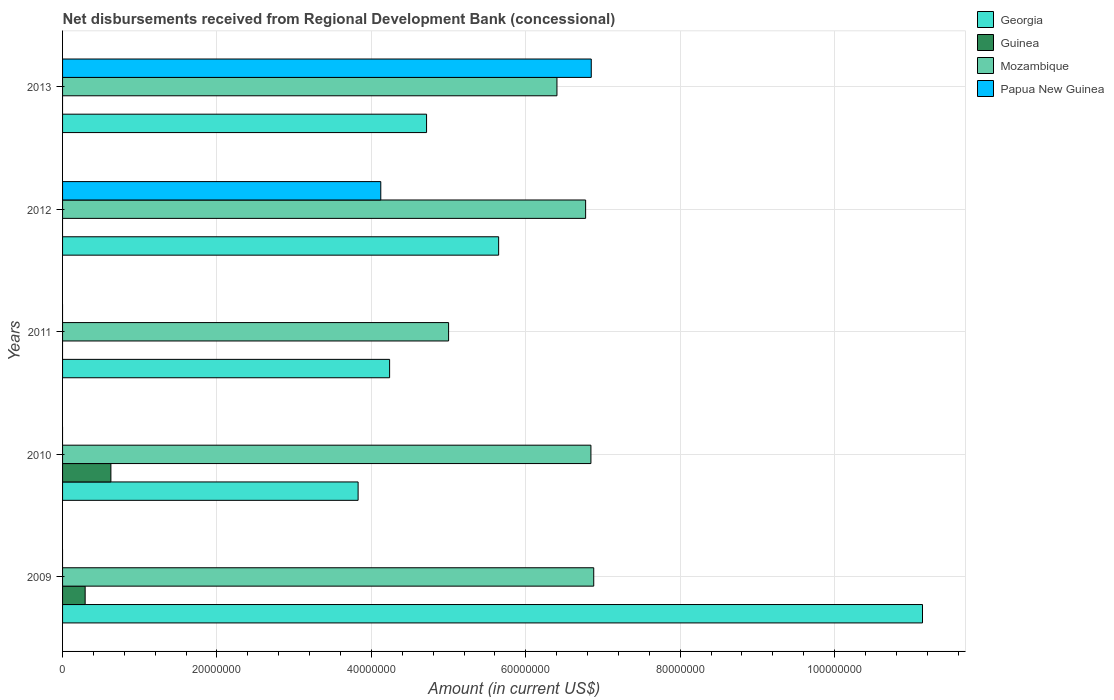How many different coloured bars are there?
Ensure brevity in your answer.  4. In how many cases, is the number of bars for a given year not equal to the number of legend labels?
Your answer should be compact. 5. What is the amount of disbursements received from Regional Development Bank in Guinea in 2009?
Your answer should be very brief. 2.93e+06. Across all years, what is the maximum amount of disbursements received from Regional Development Bank in Mozambique?
Give a very brief answer. 6.88e+07. Across all years, what is the minimum amount of disbursements received from Regional Development Bank in Mozambique?
Provide a short and direct response. 5.00e+07. In which year was the amount of disbursements received from Regional Development Bank in Georgia maximum?
Make the answer very short. 2009. What is the total amount of disbursements received from Regional Development Bank in Mozambique in the graph?
Keep it short and to the point. 3.19e+08. What is the difference between the amount of disbursements received from Regional Development Bank in Georgia in 2012 and that in 2013?
Provide a succinct answer. 9.34e+06. What is the difference between the amount of disbursements received from Regional Development Bank in Georgia in 2011 and the amount of disbursements received from Regional Development Bank in Guinea in 2012?
Your answer should be very brief. 4.24e+07. What is the average amount of disbursements received from Regional Development Bank in Mozambique per year?
Make the answer very short. 6.38e+07. In the year 2011, what is the difference between the amount of disbursements received from Regional Development Bank in Mozambique and amount of disbursements received from Regional Development Bank in Georgia?
Offer a very short reply. 7.64e+06. What is the ratio of the amount of disbursements received from Regional Development Bank in Papua New Guinea in 2012 to that in 2013?
Provide a succinct answer. 0.6. Is the amount of disbursements received from Regional Development Bank in Georgia in 2010 less than that in 2013?
Make the answer very short. Yes. Is the difference between the amount of disbursements received from Regional Development Bank in Mozambique in 2010 and 2011 greater than the difference between the amount of disbursements received from Regional Development Bank in Georgia in 2010 and 2011?
Ensure brevity in your answer.  Yes. What is the difference between the highest and the second highest amount of disbursements received from Regional Development Bank in Georgia?
Offer a very short reply. 5.49e+07. What is the difference between the highest and the lowest amount of disbursements received from Regional Development Bank in Papua New Guinea?
Your answer should be very brief. 6.85e+07. In how many years, is the amount of disbursements received from Regional Development Bank in Papua New Guinea greater than the average amount of disbursements received from Regional Development Bank in Papua New Guinea taken over all years?
Provide a short and direct response. 2. Is the sum of the amount of disbursements received from Regional Development Bank in Georgia in 2009 and 2013 greater than the maximum amount of disbursements received from Regional Development Bank in Mozambique across all years?
Your answer should be very brief. Yes. Does the graph contain grids?
Provide a short and direct response. Yes. How are the legend labels stacked?
Give a very brief answer. Vertical. What is the title of the graph?
Keep it short and to the point. Net disbursements received from Regional Development Bank (concessional). Does "Nepal" appear as one of the legend labels in the graph?
Offer a terse response. No. What is the label or title of the Y-axis?
Provide a succinct answer. Years. What is the Amount (in current US$) in Georgia in 2009?
Give a very brief answer. 1.11e+08. What is the Amount (in current US$) in Guinea in 2009?
Provide a succinct answer. 2.93e+06. What is the Amount (in current US$) of Mozambique in 2009?
Offer a terse response. 6.88e+07. What is the Amount (in current US$) of Georgia in 2010?
Your answer should be compact. 3.83e+07. What is the Amount (in current US$) of Guinea in 2010?
Keep it short and to the point. 6.26e+06. What is the Amount (in current US$) of Mozambique in 2010?
Your response must be concise. 6.84e+07. What is the Amount (in current US$) in Georgia in 2011?
Offer a very short reply. 4.24e+07. What is the Amount (in current US$) of Guinea in 2011?
Keep it short and to the point. 0. What is the Amount (in current US$) of Mozambique in 2011?
Your response must be concise. 5.00e+07. What is the Amount (in current US$) in Georgia in 2012?
Ensure brevity in your answer.  5.65e+07. What is the Amount (in current US$) in Guinea in 2012?
Give a very brief answer. 0. What is the Amount (in current US$) in Mozambique in 2012?
Offer a very short reply. 6.78e+07. What is the Amount (in current US$) in Papua New Guinea in 2012?
Offer a very short reply. 4.12e+07. What is the Amount (in current US$) of Georgia in 2013?
Your answer should be compact. 4.72e+07. What is the Amount (in current US$) in Mozambique in 2013?
Your answer should be compact. 6.40e+07. What is the Amount (in current US$) of Papua New Guinea in 2013?
Offer a terse response. 6.85e+07. Across all years, what is the maximum Amount (in current US$) in Georgia?
Keep it short and to the point. 1.11e+08. Across all years, what is the maximum Amount (in current US$) of Guinea?
Offer a very short reply. 6.26e+06. Across all years, what is the maximum Amount (in current US$) in Mozambique?
Offer a very short reply. 6.88e+07. Across all years, what is the maximum Amount (in current US$) of Papua New Guinea?
Offer a terse response. 6.85e+07. Across all years, what is the minimum Amount (in current US$) in Georgia?
Offer a terse response. 3.83e+07. Across all years, what is the minimum Amount (in current US$) of Guinea?
Ensure brevity in your answer.  0. Across all years, what is the minimum Amount (in current US$) of Mozambique?
Your answer should be compact. 5.00e+07. What is the total Amount (in current US$) in Georgia in the graph?
Provide a short and direct response. 2.96e+08. What is the total Amount (in current US$) in Guinea in the graph?
Offer a very short reply. 9.18e+06. What is the total Amount (in current US$) in Mozambique in the graph?
Provide a short and direct response. 3.19e+08. What is the total Amount (in current US$) in Papua New Guinea in the graph?
Make the answer very short. 1.10e+08. What is the difference between the Amount (in current US$) of Georgia in 2009 and that in 2010?
Ensure brevity in your answer.  7.31e+07. What is the difference between the Amount (in current US$) in Guinea in 2009 and that in 2010?
Make the answer very short. -3.33e+06. What is the difference between the Amount (in current US$) in Mozambique in 2009 and that in 2010?
Give a very brief answer. 3.64e+05. What is the difference between the Amount (in current US$) of Georgia in 2009 and that in 2011?
Your answer should be compact. 6.90e+07. What is the difference between the Amount (in current US$) in Mozambique in 2009 and that in 2011?
Your answer should be compact. 1.88e+07. What is the difference between the Amount (in current US$) of Georgia in 2009 and that in 2012?
Offer a terse response. 5.49e+07. What is the difference between the Amount (in current US$) in Mozambique in 2009 and that in 2012?
Your answer should be compact. 1.05e+06. What is the difference between the Amount (in current US$) in Georgia in 2009 and that in 2013?
Your answer should be very brief. 6.42e+07. What is the difference between the Amount (in current US$) of Mozambique in 2009 and that in 2013?
Your answer should be compact. 4.76e+06. What is the difference between the Amount (in current US$) in Georgia in 2010 and that in 2011?
Your answer should be very brief. -4.08e+06. What is the difference between the Amount (in current US$) in Mozambique in 2010 and that in 2011?
Give a very brief answer. 1.84e+07. What is the difference between the Amount (in current US$) of Georgia in 2010 and that in 2012?
Make the answer very short. -1.82e+07. What is the difference between the Amount (in current US$) in Mozambique in 2010 and that in 2012?
Make the answer very short. 6.87e+05. What is the difference between the Amount (in current US$) in Georgia in 2010 and that in 2013?
Ensure brevity in your answer.  -8.87e+06. What is the difference between the Amount (in current US$) in Mozambique in 2010 and that in 2013?
Provide a succinct answer. 4.40e+06. What is the difference between the Amount (in current US$) in Georgia in 2011 and that in 2012?
Offer a very short reply. -1.41e+07. What is the difference between the Amount (in current US$) of Mozambique in 2011 and that in 2012?
Your answer should be compact. -1.78e+07. What is the difference between the Amount (in current US$) in Georgia in 2011 and that in 2013?
Offer a very short reply. -4.79e+06. What is the difference between the Amount (in current US$) in Mozambique in 2011 and that in 2013?
Your answer should be compact. -1.40e+07. What is the difference between the Amount (in current US$) of Georgia in 2012 and that in 2013?
Your answer should be very brief. 9.34e+06. What is the difference between the Amount (in current US$) in Mozambique in 2012 and that in 2013?
Your answer should be compact. 3.71e+06. What is the difference between the Amount (in current US$) of Papua New Guinea in 2012 and that in 2013?
Make the answer very short. -2.73e+07. What is the difference between the Amount (in current US$) of Georgia in 2009 and the Amount (in current US$) of Guinea in 2010?
Make the answer very short. 1.05e+08. What is the difference between the Amount (in current US$) of Georgia in 2009 and the Amount (in current US$) of Mozambique in 2010?
Your response must be concise. 4.29e+07. What is the difference between the Amount (in current US$) of Guinea in 2009 and the Amount (in current US$) of Mozambique in 2010?
Offer a very short reply. -6.55e+07. What is the difference between the Amount (in current US$) of Georgia in 2009 and the Amount (in current US$) of Mozambique in 2011?
Offer a terse response. 6.14e+07. What is the difference between the Amount (in current US$) in Guinea in 2009 and the Amount (in current US$) in Mozambique in 2011?
Offer a terse response. -4.71e+07. What is the difference between the Amount (in current US$) of Georgia in 2009 and the Amount (in current US$) of Mozambique in 2012?
Keep it short and to the point. 4.36e+07. What is the difference between the Amount (in current US$) in Georgia in 2009 and the Amount (in current US$) in Papua New Guinea in 2012?
Provide a short and direct response. 7.02e+07. What is the difference between the Amount (in current US$) in Guinea in 2009 and the Amount (in current US$) in Mozambique in 2012?
Your answer should be compact. -6.48e+07. What is the difference between the Amount (in current US$) in Guinea in 2009 and the Amount (in current US$) in Papua New Guinea in 2012?
Offer a very short reply. -3.83e+07. What is the difference between the Amount (in current US$) in Mozambique in 2009 and the Amount (in current US$) in Papua New Guinea in 2012?
Make the answer very short. 2.76e+07. What is the difference between the Amount (in current US$) in Georgia in 2009 and the Amount (in current US$) in Mozambique in 2013?
Offer a terse response. 4.73e+07. What is the difference between the Amount (in current US$) of Georgia in 2009 and the Amount (in current US$) of Papua New Guinea in 2013?
Provide a short and direct response. 4.29e+07. What is the difference between the Amount (in current US$) of Guinea in 2009 and the Amount (in current US$) of Mozambique in 2013?
Keep it short and to the point. -6.11e+07. What is the difference between the Amount (in current US$) of Guinea in 2009 and the Amount (in current US$) of Papua New Guinea in 2013?
Give a very brief answer. -6.56e+07. What is the difference between the Amount (in current US$) in Georgia in 2010 and the Amount (in current US$) in Mozambique in 2011?
Your answer should be compact. -1.17e+07. What is the difference between the Amount (in current US$) in Guinea in 2010 and the Amount (in current US$) in Mozambique in 2011?
Offer a terse response. -4.37e+07. What is the difference between the Amount (in current US$) in Georgia in 2010 and the Amount (in current US$) in Mozambique in 2012?
Your response must be concise. -2.95e+07. What is the difference between the Amount (in current US$) in Georgia in 2010 and the Amount (in current US$) in Papua New Guinea in 2012?
Offer a terse response. -2.94e+06. What is the difference between the Amount (in current US$) in Guinea in 2010 and the Amount (in current US$) in Mozambique in 2012?
Offer a terse response. -6.15e+07. What is the difference between the Amount (in current US$) in Guinea in 2010 and the Amount (in current US$) in Papua New Guinea in 2012?
Offer a very short reply. -3.50e+07. What is the difference between the Amount (in current US$) in Mozambique in 2010 and the Amount (in current US$) in Papua New Guinea in 2012?
Your answer should be very brief. 2.72e+07. What is the difference between the Amount (in current US$) of Georgia in 2010 and the Amount (in current US$) of Mozambique in 2013?
Give a very brief answer. -2.58e+07. What is the difference between the Amount (in current US$) in Georgia in 2010 and the Amount (in current US$) in Papua New Guinea in 2013?
Give a very brief answer. -3.02e+07. What is the difference between the Amount (in current US$) of Guinea in 2010 and the Amount (in current US$) of Mozambique in 2013?
Your answer should be compact. -5.78e+07. What is the difference between the Amount (in current US$) of Guinea in 2010 and the Amount (in current US$) of Papua New Guinea in 2013?
Give a very brief answer. -6.22e+07. What is the difference between the Amount (in current US$) of Mozambique in 2010 and the Amount (in current US$) of Papua New Guinea in 2013?
Your answer should be compact. -4.40e+04. What is the difference between the Amount (in current US$) in Georgia in 2011 and the Amount (in current US$) in Mozambique in 2012?
Provide a succinct answer. -2.54e+07. What is the difference between the Amount (in current US$) in Georgia in 2011 and the Amount (in current US$) in Papua New Guinea in 2012?
Offer a very short reply. 1.14e+06. What is the difference between the Amount (in current US$) of Mozambique in 2011 and the Amount (in current US$) of Papua New Guinea in 2012?
Make the answer very short. 8.78e+06. What is the difference between the Amount (in current US$) in Georgia in 2011 and the Amount (in current US$) in Mozambique in 2013?
Provide a succinct answer. -2.17e+07. What is the difference between the Amount (in current US$) of Georgia in 2011 and the Amount (in current US$) of Papua New Guinea in 2013?
Your response must be concise. -2.61e+07. What is the difference between the Amount (in current US$) in Mozambique in 2011 and the Amount (in current US$) in Papua New Guinea in 2013?
Offer a very short reply. -1.85e+07. What is the difference between the Amount (in current US$) in Georgia in 2012 and the Amount (in current US$) in Mozambique in 2013?
Offer a very short reply. -7.55e+06. What is the difference between the Amount (in current US$) of Georgia in 2012 and the Amount (in current US$) of Papua New Guinea in 2013?
Offer a very short reply. -1.20e+07. What is the difference between the Amount (in current US$) of Mozambique in 2012 and the Amount (in current US$) of Papua New Guinea in 2013?
Offer a terse response. -7.31e+05. What is the average Amount (in current US$) in Georgia per year?
Your answer should be compact. 5.91e+07. What is the average Amount (in current US$) in Guinea per year?
Ensure brevity in your answer.  1.84e+06. What is the average Amount (in current US$) in Mozambique per year?
Provide a short and direct response. 6.38e+07. What is the average Amount (in current US$) of Papua New Guinea per year?
Offer a very short reply. 2.19e+07. In the year 2009, what is the difference between the Amount (in current US$) in Georgia and Amount (in current US$) in Guinea?
Give a very brief answer. 1.08e+08. In the year 2009, what is the difference between the Amount (in current US$) in Georgia and Amount (in current US$) in Mozambique?
Give a very brief answer. 4.26e+07. In the year 2009, what is the difference between the Amount (in current US$) of Guinea and Amount (in current US$) of Mozambique?
Offer a terse response. -6.59e+07. In the year 2010, what is the difference between the Amount (in current US$) in Georgia and Amount (in current US$) in Guinea?
Your response must be concise. 3.20e+07. In the year 2010, what is the difference between the Amount (in current US$) of Georgia and Amount (in current US$) of Mozambique?
Ensure brevity in your answer.  -3.02e+07. In the year 2010, what is the difference between the Amount (in current US$) in Guinea and Amount (in current US$) in Mozambique?
Your answer should be very brief. -6.22e+07. In the year 2011, what is the difference between the Amount (in current US$) of Georgia and Amount (in current US$) of Mozambique?
Your response must be concise. -7.64e+06. In the year 2012, what is the difference between the Amount (in current US$) in Georgia and Amount (in current US$) in Mozambique?
Your response must be concise. -1.13e+07. In the year 2012, what is the difference between the Amount (in current US$) of Georgia and Amount (in current US$) of Papua New Guinea?
Provide a short and direct response. 1.53e+07. In the year 2012, what is the difference between the Amount (in current US$) of Mozambique and Amount (in current US$) of Papua New Guinea?
Keep it short and to the point. 2.65e+07. In the year 2013, what is the difference between the Amount (in current US$) in Georgia and Amount (in current US$) in Mozambique?
Give a very brief answer. -1.69e+07. In the year 2013, what is the difference between the Amount (in current US$) in Georgia and Amount (in current US$) in Papua New Guinea?
Your answer should be compact. -2.13e+07. In the year 2013, what is the difference between the Amount (in current US$) in Mozambique and Amount (in current US$) in Papua New Guinea?
Provide a short and direct response. -4.44e+06. What is the ratio of the Amount (in current US$) of Georgia in 2009 to that in 2010?
Provide a short and direct response. 2.91. What is the ratio of the Amount (in current US$) in Guinea in 2009 to that in 2010?
Offer a very short reply. 0.47. What is the ratio of the Amount (in current US$) in Georgia in 2009 to that in 2011?
Make the answer very short. 2.63. What is the ratio of the Amount (in current US$) of Mozambique in 2009 to that in 2011?
Your answer should be very brief. 1.38. What is the ratio of the Amount (in current US$) of Georgia in 2009 to that in 2012?
Provide a succinct answer. 1.97. What is the ratio of the Amount (in current US$) in Mozambique in 2009 to that in 2012?
Offer a very short reply. 1.02. What is the ratio of the Amount (in current US$) of Georgia in 2009 to that in 2013?
Keep it short and to the point. 2.36. What is the ratio of the Amount (in current US$) of Mozambique in 2009 to that in 2013?
Ensure brevity in your answer.  1.07. What is the ratio of the Amount (in current US$) in Georgia in 2010 to that in 2011?
Your answer should be very brief. 0.9. What is the ratio of the Amount (in current US$) of Mozambique in 2010 to that in 2011?
Your answer should be very brief. 1.37. What is the ratio of the Amount (in current US$) in Georgia in 2010 to that in 2012?
Give a very brief answer. 0.68. What is the ratio of the Amount (in current US$) in Mozambique in 2010 to that in 2012?
Give a very brief answer. 1.01. What is the ratio of the Amount (in current US$) in Georgia in 2010 to that in 2013?
Your answer should be compact. 0.81. What is the ratio of the Amount (in current US$) of Mozambique in 2010 to that in 2013?
Make the answer very short. 1.07. What is the ratio of the Amount (in current US$) in Mozambique in 2011 to that in 2012?
Keep it short and to the point. 0.74. What is the ratio of the Amount (in current US$) of Georgia in 2011 to that in 2013?
Ensure brevity in your answer.  0.9. What is the ratio of the Amount (in current US$) of Mozambique in 2011 to that in 2013?
Offer a very short reply. 0.78. What is the ratio of the Amount (in current US$) of Georgia in 2012 to that in 2013?
Offer a terse response. 1.2. What is the ratio of the Amount (in current US$) of Mozambique in 2012 to that in 2013?
Make the answer very short. 1.06. What is the ratio of the Amount (in current US$) of Papua New Guinea in 2012 to that in 2013?
Give a very brief answer. 0.6. What is the difference between the highest and the second highest Amount (in current US$) of Georgia?
Make the answer very short. 5.49e+07. What is the difference between the highest and the second highest Amount (in current US$) in Mozambique?
Keep it short and to the point. 3.64e+05. What is the difference between the highest and the lowest Amount (in current US$) of Georgia?
Offer a very short reply. 7.31e+07. What is the difference between the highest and the lowest Amount (in current US$) in Guinea?
Your response must be concise. 6.26e+06. What is the difference between the highest and the lowest Amount (in current US$) of Mozambique?
Your answer should be very brief. 1.88e+07. What is the difference between the highest and the lowest Amount (in current US$) in Papua New Guinea?
Provide a succinct answer. 6.85e+07. 